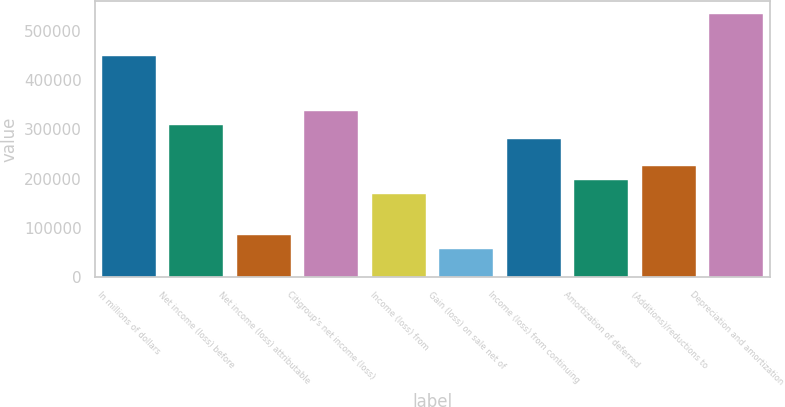<chart> <loc_0><loc_0><loc_500><loc_500><bar_chart><fcel>In millions of dollars<fcel>Net income (loss) before<fcel>Net income (loss) attributable<fcel>Citigroup's net income (loss)<fcel>Income (loss) from<fcel>Gain (loss) on sale net of<fcel>Income (loss) from continuing<fcel>Amortization of deferred<fcel>(Additions)/reductions to<fcel>Depreciation and amortization<nl><fcel>449782<fcel>309226<fcel>84336.6<fcel>337337<fcel>168670<fcel>56225.4<fcel>281115<fcel>196781<fcel>224893<fcel>534116<nl></chart> 